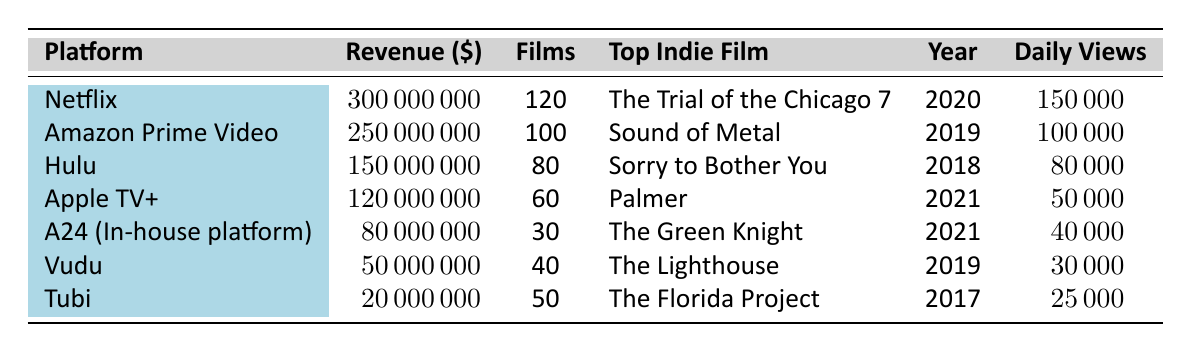What is the total revenue from independent films across all platforms? To find the total revenue, we sum the revenue from each streaming platform: 300,000,000 (Netflix) + 250,000,000 (Amazon Prime Video) + 150,000,000 (Hulu) + 120,000,000 (Apple TV+) + 80,000,000 (A24) + 50,000,000 (Vudu) + 20,000,000 (Tubi) = 970,000,000.
Answer: 970,000,000 Which platform has the highest number of indie films? By examining the "Films" column, Netflix has 120 films, which is more than any other platform listed.
Answer: Netflix What is the average daily view count for indie films on Hulu? The daily views for Hulu are 80,000. Since there is only one entry for Hulu, the average is the same as the daily view count.
Answer: 80,000 Is "Sound of Metal" available on the platform with the second highest revenue? The second highest revenue platform is Amazon Prime Video, and "Sound of Metal" is listed as its top indie film. So yes, it is available on that platform.
Answer: Yes Which platform generates more revenue from indie films, Apple TV+ or A24? Apple TV+ has a revenue of 120,000,000 while A24 has 80,000,000. Since 120,000,000 > 80,000,000, Apple TV+ generates more revenue than A24.
Answer: Apple TV+ What is the total number of indie films available on Vudu and Tubi combined? Vudu has 40 films and Tubi has 50 films. Adding these together gives 40 + 50 = 90 films.
Answer: 90 Which year did the top indie film on A24 come out? The top indie film on A24 is "The Green Knight," and it was released in 2021 according to the table.
Answer: 2021 If we look at all platforms, how many indie films were released in or after 2020? The films from Netflix (released in 2020), Apple TV+ (released in 2021), and A24 (released in 2021) contribute to indie films released in or after 2020: 120 + 60 + 30 = 210 films.
Answer: 210 What is the average revenue produced by indie films on the streaming platforms listed? To find the average revenue, we first total the revenue which is 970,000,000. Next, we divide this by the number of platforms (7) to get an average of 970,000,000 / 7 ≈ 138,571,429.
Answer: 138,571,429 Does Hulu have a lower average daily view count compared to Apple TV+? Hulu's average daily views are 80,000 and Apple TV+ has 50,000. Comparing these values shows that 80,000 is greater than 50,000, so Hulu does not have a lower average.
Answer: No 